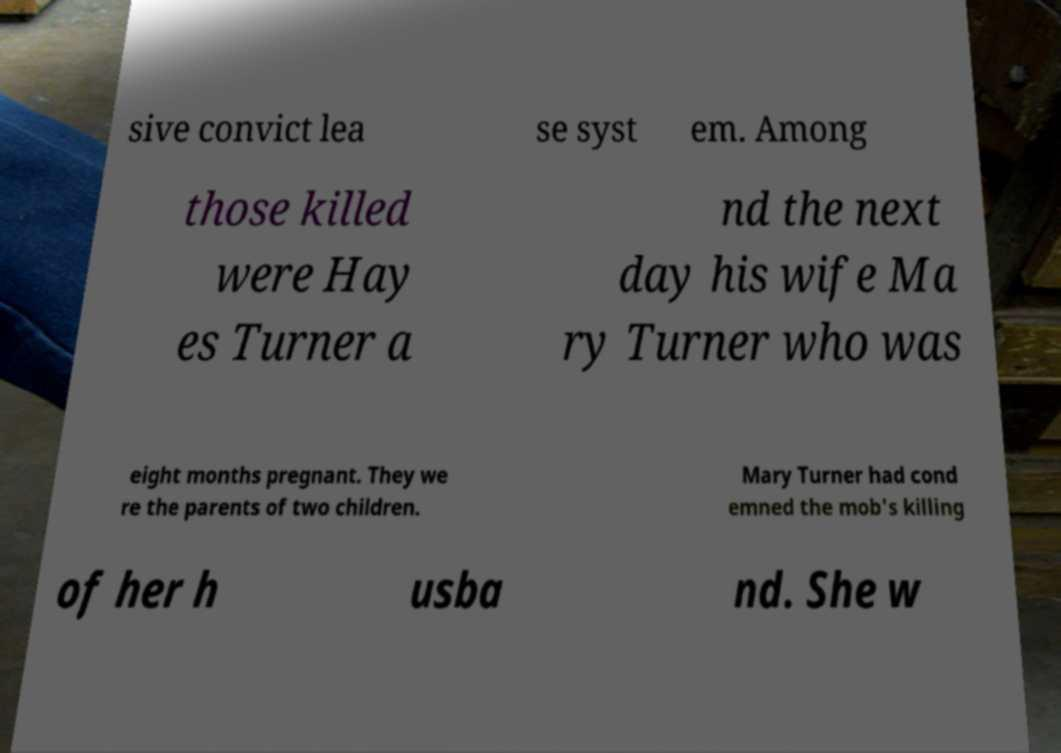What messages or text are displayed in this image? I need them in a readable, typed format. sive convict lea se syst em. Among those killed were Hay es Turner a nd the next day his wife Ma ry Turner who was eight months pregnant. They we re the parents of two children. Mary Turner had cond emned the mob's killing of her h usba nd. She w 